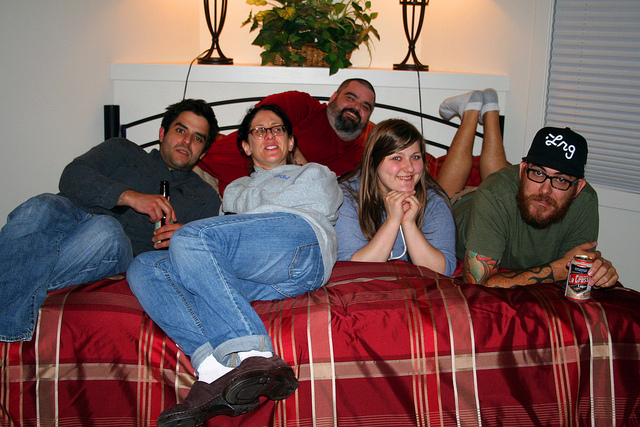Please extract the text content from this image. Jng 